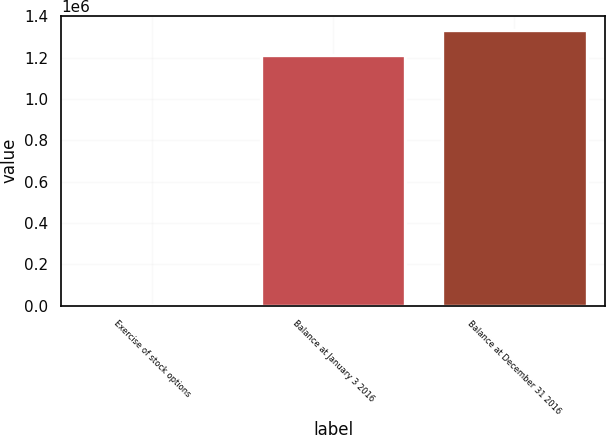Convert chart. <chart><loc_0><loc_0><loc_500><loc_500><bar_chart><fcel>Exercise of stock options<fcel>Balance at January 3 2016<fcel>Balance at December 31 2016<nl><fcel>1925<fcel>1.21398e+06<fcel>1.33543e+06<nl></chart> 